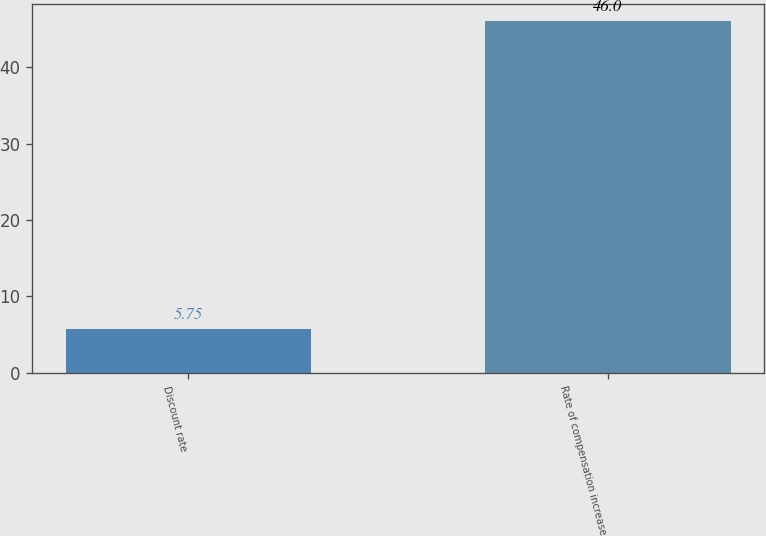Convert chart to OTSL. <chart><loc_0><loc_0><loc_500><loc_500><bar_chart><fcel>Discount rate<fcel>Rate of compensation increase<nl><fcel>5.75<fcel>46<nl></chart> 